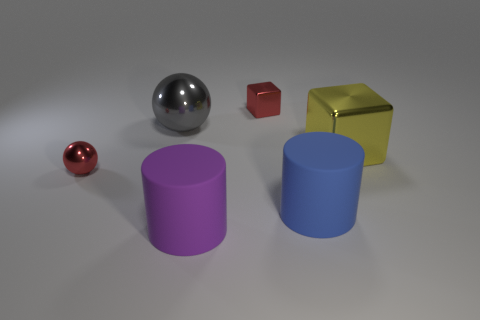Are there the same number of red cubes that are on the left side of the small metallic sphere and small red objects in front of the large yellow metallic thing?
Your response must be concise. No. How big is the metal sphere in front of the large gray thing?
Your response must be concise. Small. Do the big metallic sphere and the large cube have the same color?
Ensure brevity in your answer.  No. Are there any other things that have the same shape as the purple rubber thing?
Provide a short and direct response. Yes. There is a small ball that is the same color as the tiny shiny block; what is its material?
Ensure brevity in your answer.  Metal. Is the number of objects that are in front of the gray shiny sphere the same as the number of large brown cylinders?
Provide a short and direct response. No. Are there any large metal objects behind the yellow metallic object?
Your response must be concise. Yes. Does the gray metallic object have the same shape as the small metal thing that is on the right side of the purple rubber thing?
Your response must be concise. No. What color is the tiny sphere that is the same material as the large yellow cube?
Ensure brevity in your answer.  Red. The large block has what color?
Offer a very short reply. Yellow. 